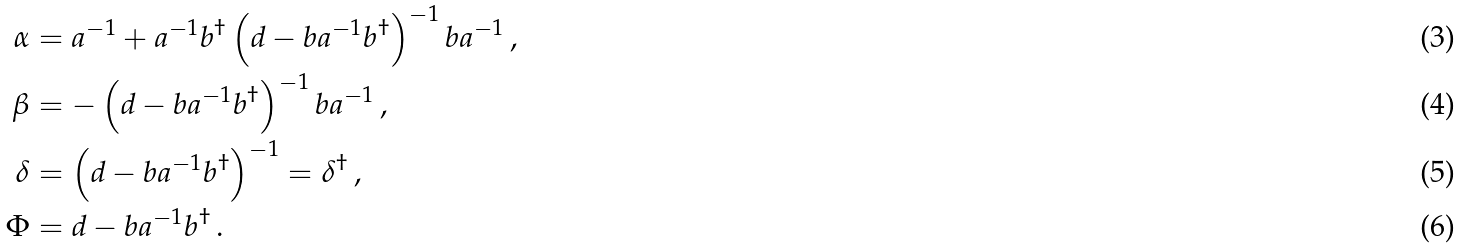<formula> <loc_0><loc_0><loc_500><loc_500>\alpha & = a ^ { - 1 } + a ^ { - 1 } b ^ { \dag } \left ( d - b a ^ { - 1 } b ^ { \dag } \right ) ^ { - 1 } b a ^ { - 1 } \, , \\ \beta & = - \left ( d - b a ^ { - 1 } b ^ { \dag } \right ) ^ { - 1 } b a ^ { - 1 } \, , \\ \delta & = \left ( d - b a ^ { - 1 } b ^ { \dag } \right ) ^ { - 1 } = \delta ^ { \dag } \, , \\ \Phi & = d - b a ^ { - 1 } b ^ { \dag } \, .</formula> 